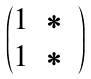Convert formula to latex. <formula><loc_0><loc_0><loc_500><loc_500>\begin{pmatrix} 1 & \ast & \\ 1 & \ast \end{pmatrix}</formula> 